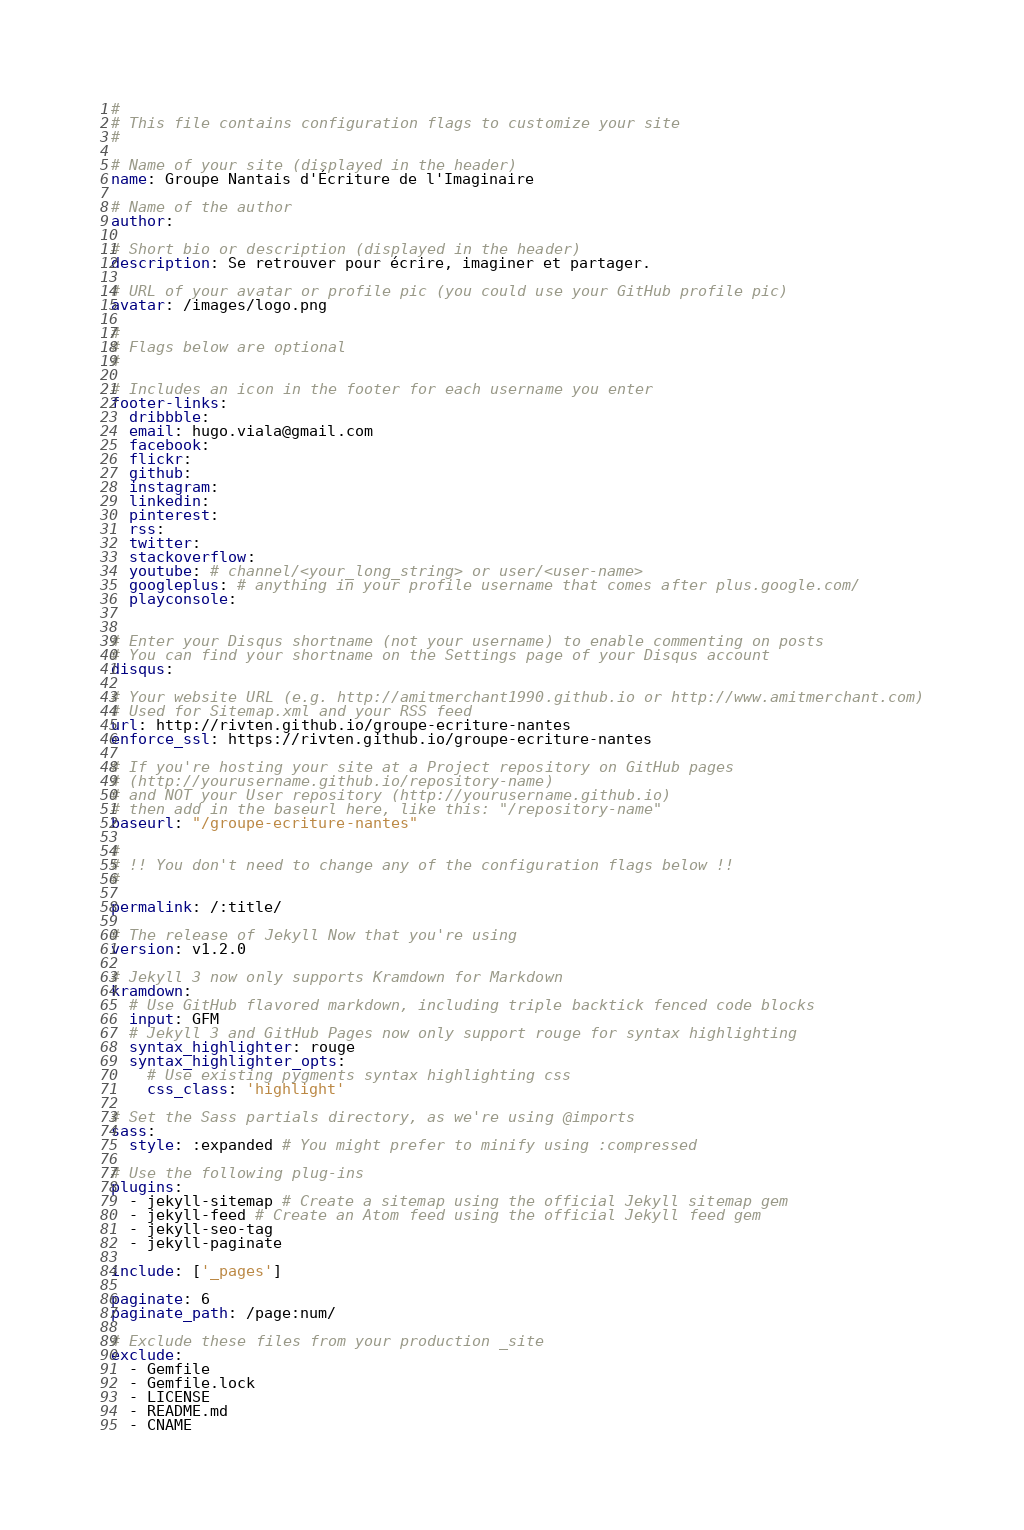<code> <loc_0><loc_0><loc_500><loc_500><_YAML_>#
# This file contains configuration flags to customize your site
#

# Name of your site (displayed in the header)
name: Groupe Nantais d'Écriture de l'Imaginaire

# Name of the author
author:

# Short bio or description (displayed in the header)
description: Se retrouver pour écrire, imaginer et partager.

# URL of your avatar or profile pic (you could use your GitHub profile pic)
avatar: /images/logo.png

#
# Flags below are optional
#

# Includes an icon in the footer for each username you enter
footer-links:
  dribbble:
  email: hugo.viala@gmail.com
  facebook:
  flickr:
  github:
  instagram:
  linkedin: 
  pinterest:
  rss:
  twitter:
  stackoverflow: 
  youtube: # channel/<your_long_string> or user/<user-name>
  googleplus: # anything in your profile username that comes after plus.google.com/
  playconsole:


# Enter your Disqus shortname (not your username) to enable commenting on posts
# You can find your shortname on the Settings page of your Disqus account
disqus: 

# Your website URL (e.g. http://amitmerchant1990.github.io or http://www.amitmerchant.com)
# Used for Sitemap.xml and your RSS feed
url: http://rivten.github.io/groupe-ecriture-nantes
enforce_ssl: https://rivten.github.io/groupe-ecriture-nantes

# If you're hosting your site at a Project repository on GitHub pages
# (http://yourusername.github.io/repository-name)
# and NOT your User repository (http://yourusername.github.io)
# then add in the baseurl here, like this: "/repository-name"
baseurl: "/groupe-ecriture-nantes"

#
# !! You don't need to change any of the configuration flags below !!
#

permalink: /:title/

# The release of Jekyll Now that you're using
version: v1.2.0

# Jekyll 3 now only supports Kramdown for Markdown
kramdown:
  # Use GitHub flavored markdown, including triple backtick fenced code blocks
  input: GFM
  # Jekyll 3 and GitHub Pages now only support rouge for syntax highlighting
  syntax_highlighter: rouge
  syntax_highlighter_opts:
    # Use existing pygments syntax highlighting css
    css_class: 'highlight'

# Set the Sass partials directory, as we're using @imports
sass:
  style: :expanded # You might prefer to minify using :compressed

# Use the following plug-ins
plugins:
  - jekyll-sitemap # Create a sitemap using the official Jekyll sitemap gem
  - jekyll-feed # Create an Atom feed using the official Jekyll feed gem
  - jekyll-seo-tag
  - jekyll-paginate

include: ['_pages']

paginate: 6
paginate_path: /page:num/

# Exclude these files from your production _site
exclude:
  - Gemfile
  - Gemfile.lock
  - LICENSE
  - README.md
  - CNAME

</code> 